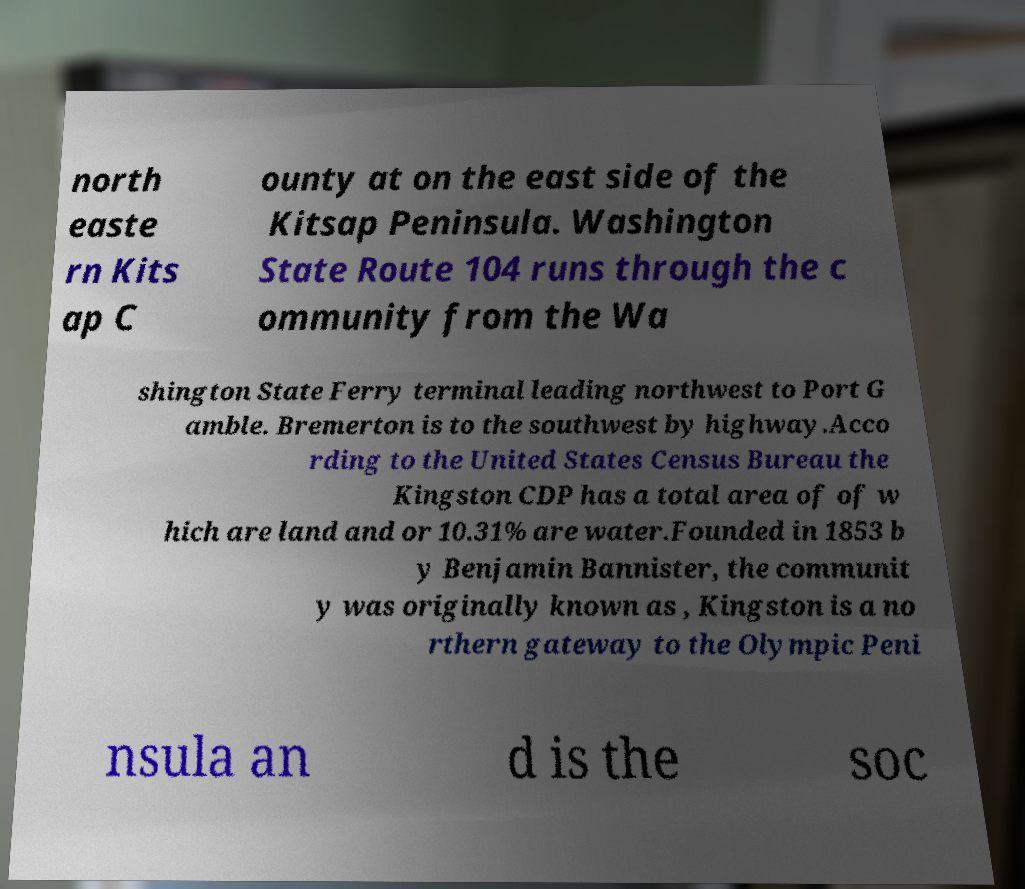For documentation purposes, I need the text within this image transcribed. Could you provide that? north easte rn Kits ap C ounty at on the east side of the Kitsap Peninsula. Washington State Route 104 runs through the c ommunity from the Wa shington State Ferry terminal leading northwest to Port G amble. Bremerton is to the southwest by highway.Acco rding to the United States Census Bureau the Kingston CDP has a total area of of w hich are land and or 10.31% are water.Founded in 1853 b y Benjamin Bannister, the communit y was originally known as , Kingston is a no rthern gateway to the Olympic Peni nsula an d is the soc 